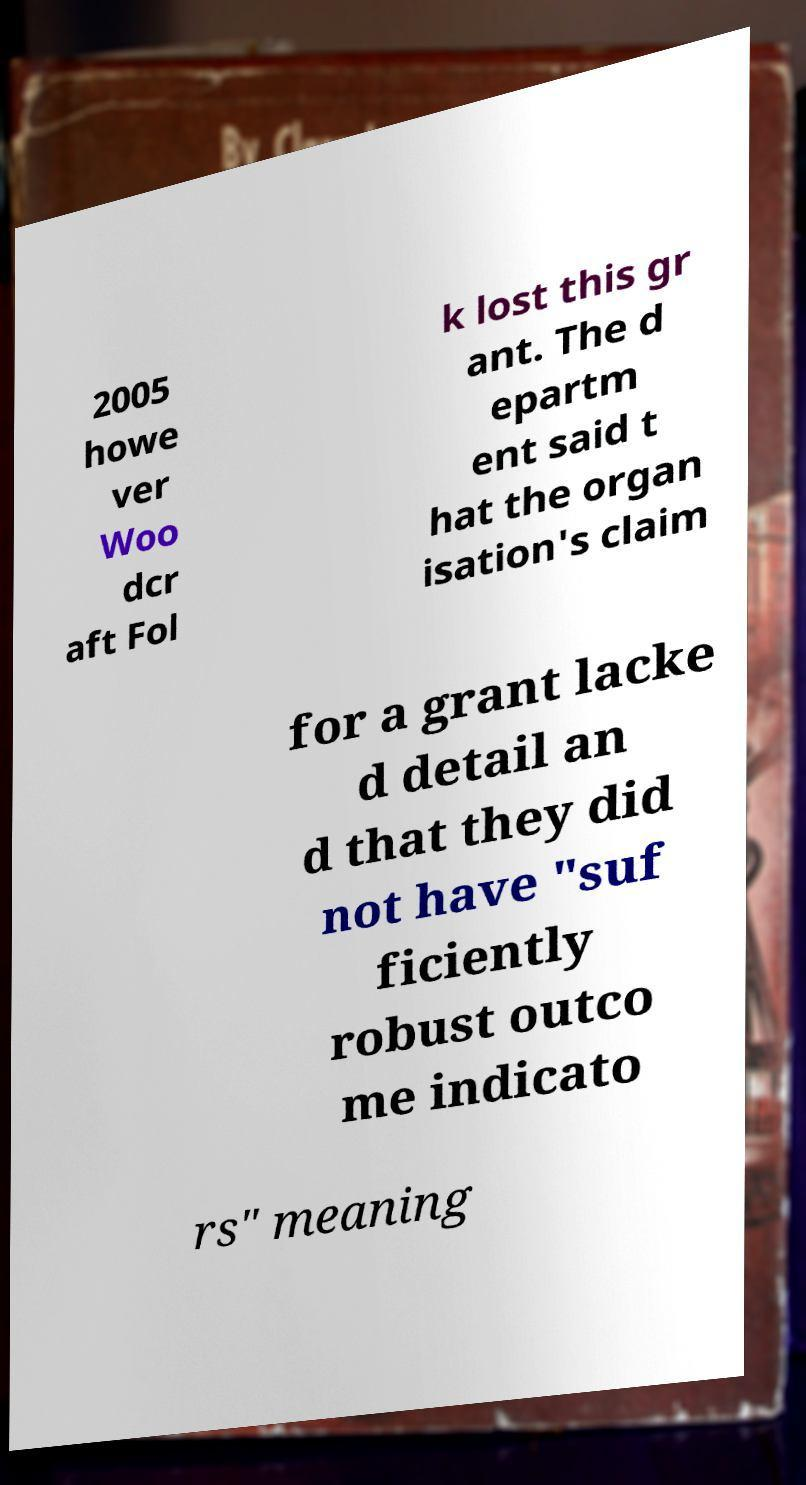For documentation purposes, I need the text within this image transcribed. Could you provide that? 2005 howe ver Woo dcr aft Fol k lost this gr ant. The d epartm ent said t hat the organ isation's claim for a grant lacke d detail an d that they did not have "suf ficiently robust outco me indicato rs" meaning 